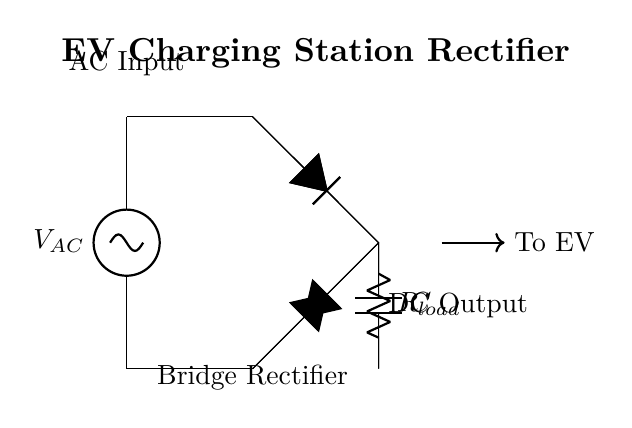What is the AC voltage source labeled as? The diagram labels the AC voltage source as "V_AC," indicating it is the primary input voltage for the circuit.
Answer: V_AC How many diodes are in the bridge rectifier? Observing the circuit, there are four diodes connected in a specific arrangement to form the bridge rectifier configuration.
Answer: Four What component stores energy after rectification? The capacitor labeled "C" is utilized in the circuit to store energy, smoothing the DC output after rectification.
Answer: C What is the function of the load resistor? The load resistor, labeled "R_load," is used to simulate a load that the rectified output voltage will power, allowing analysis of the rectifier's performance.
Answer: R_load What type of circuit is depicted in this diagram? The circuit illustrated is specifically a bridge rectifier circuit, which is characterized by the arrangement of diodes designed for converting AC to DC power.
Answer: Bridge Rectifier What type of output does this circuit provide? The circuit diagram produces a direct current output, which is indicated by the label "DC Output" connected to an electric vehicle.
Answer: DC Output Which component is directly connected to the electric vehicle? The arrow in the diagram points to the connection leading to the electric vehicle, indicating that the DC output is directed there for charging purposes.
Answer: To EV 